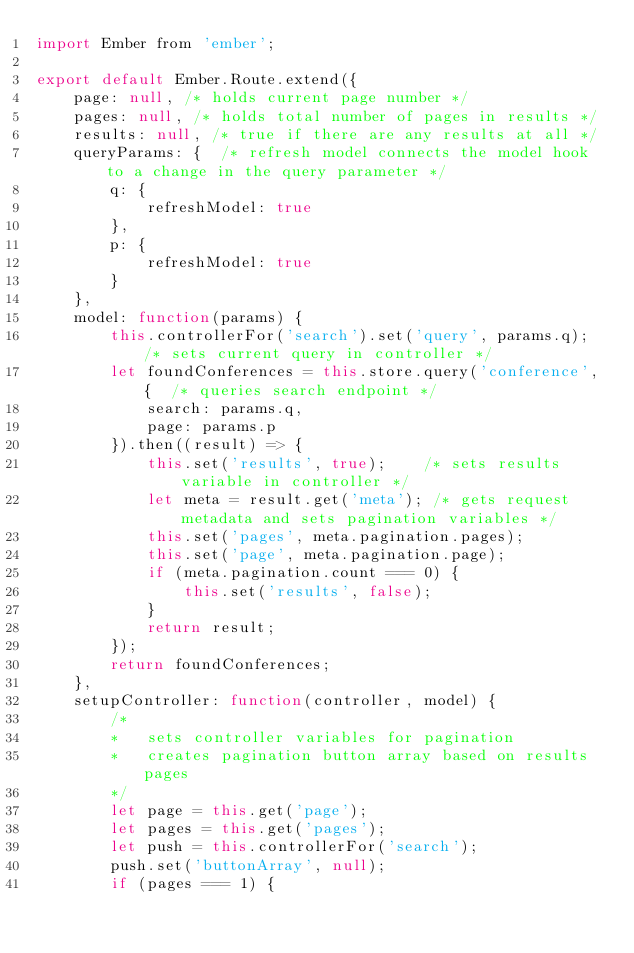<code> <loc_0><loc_0><loc_500><loc_500><_JavaScript_>import Ember from 'ember';

export default Ember.Route.extend({
    page: null, /* holds current page number */
    pages: null, /* holds total number of pages in results */
    results: null, /* true if there are any results at all */
    queryParams: {  /* refresh model connects the model hook to a change in the query parameter */
        q: {
            refreshModel: true 
        },
        p: {
            refreshModel: true
        }
    },
    model: function(params) {
        this.controllerFor('search').set('query', params.q); /* sets current query in controller */
        let foundConferences = this.store.query('conference', {  /* queries search endpoint */
            search: params.q,
            page: params.p
        }).then((result) => {
            this.set('results', true);    /* sets results variable in controller */
            let meta = result.get('meta'); /* gets request metadata and sets pagination variables */
            this.set('pages', meta.pagination.pages);
            this.set('page', meta.pagination.page);
            if (meta.pagination.count === 0) {
                this.set('results', false);
            }
            return result;
        });
        return foundConferences;
    },
    setupController: function(controller, model) {
        /*
        *   sets controller variables for pagination
        *   creates pagination button array based on results pages
        */
        let page = this.get('page');
        let pages = this.get('pages');
        let push = this.controllerFor('search');
        push.set('buttonArray', null);
        if (pages === 1) {</code> 